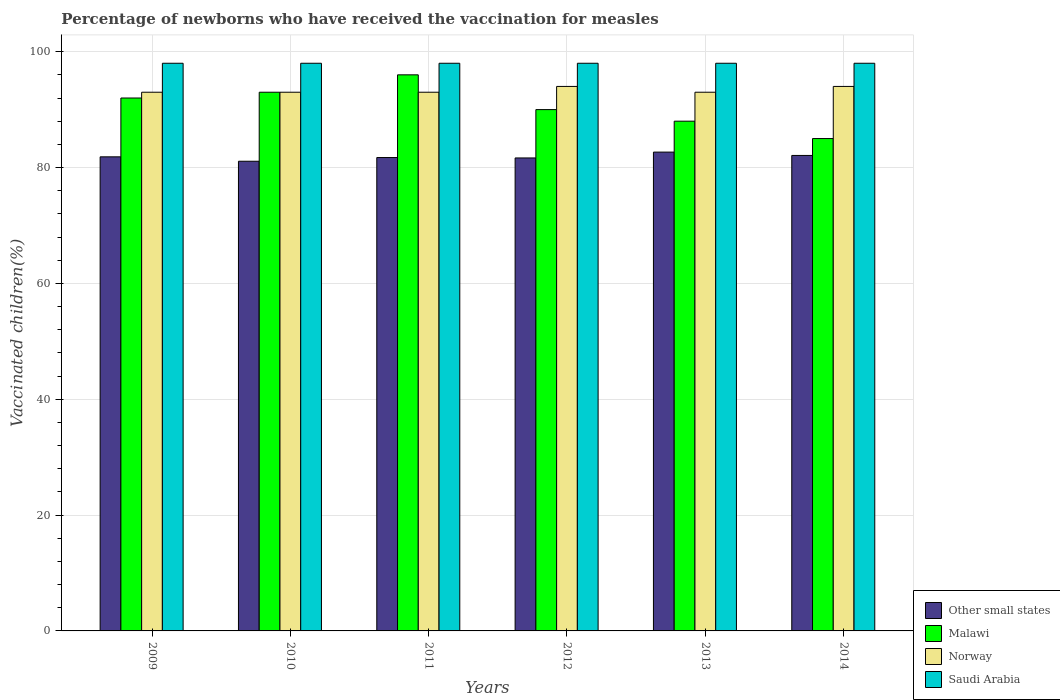What is the label of the 5th group of bars from the left?
Give a very brief answer. 2013. What is the percentage of vaccinated children in Other small states in 2012?
Provide a short and direct response. 81.65. Across all years, what is the maximum percentage of vaccinated children in Saudi Arabia?
Provide a short and direct response. 98. Across all years, what is the minimum percentage of vaccinated children in Other small states?
Make the answer very short. 81.08. In which year was the percentage of vaccinated children in Norway minimum?
Keep it short and to the point. 2009. What is the total percentage of vaccinated children in Norway in the graph?
Your response must be concise. 560. What is the difference between the percentage of vaccinated children in Norway in 2012 and that in 2013?
Your answer should be compact. 1. What is the difference between the percentage of vaccinated children in Malawi in 2011 and the percentage of vaccinated children in Other small states in 2010?
Provide a succinct answer. 14.92. What is the average percentage of vaccinated children in Norway per year?
Ensure brevity in your answer.  93.33. In the year 2011, what is the difference between the percentage of vaccinated children in Malawi and percentage of vaccinated children in Other small states?
Make the answer very short. 14.28. In how many years, is the percentage of vaccinated children in Malawi greater than 4 %?
Your response must be concise. 6. What is the ratio of the percentage of vaccinated children in Saudi Arabia in 2013 to that in 2014?
Your answer should be very brief. 1. Is the difference between the percentage of vaccinated children in Malawi in 2011 and 2014 greater than the difference between the percentage of vaccinated children in Other small states in 2011 and 2014?
Ensure brevity in your answer.  Yes. What is the difference between the highest and the second highest percentage of vaccinated children in Malawi?
Your response must be concise. 3. What is the difference between the highest and the lowest percentage of vaccinated children in Malawi?
Offer a terse response. 11. In how many years, is the percentage of vaccinated children in Norway greater than the average percentage of vaccinated children in Norway taken over all years?
Offer a terse response. 2. Is it the case that in every year, the sum of the percentage of vaccinated children in Other small states and percentage of vaccinated children in Norway is greater than the sum of percentage of vaccinated children in Saudi Arabia and percentage of vaccinated children in Malawi?
Keep it short and to the point. Yes. What does the 3rd bar from the left in 2013 represents?
Your answer should be compact. Norway. Is it the case that in every year, the sum of the percentage of vaccinated children in Norway and percentage of vaccinated children in Saudi Arabia is greater than the percentage of vaccinated children in Malawi?
Ensure brevity in your answer.  Yes. How many bars are there?
Your answer should be very brief. 24. How many years are there in the graph?
Provide a succinct answer. 6. What is the difference between two consecutive major ticks on the Y-axis?
Provide a short and direct response. 20. How are the legend labels stacked?
Ensure brevity in your answer.  Vertical. What is the title of the graph?
Your answer should be very brief. Percentage of newborns who have received the vaccination for measles. Does "Libya" appear as one of the legend labels in the graph?
Offer a terse response. No. What is the label or title of the X-axis?
Offer a terse response. Years. What is the label or title of the Y-axis?
Provide a succinct answer. Vaccinated children(%). What is the Vaccinated children(%) in Other small states in 2009?
Provide a succinct answer. 81.85. What is the Vaccinated children(%) of Malawi in 2009?
Give a very brief answer. 92. What is the Vaccinated children(%) in Norway in 2009?
Ensure brevity in your answer.  93. What is the Vaccinated children(%) in Saudi Arabia in 2009?
Your response must be concise. 98. What is the Vaccinated children(%) of Other small states in 2010?
Offer a very short reply. 81.08. What is the Vaccinated children(%) of Malawi in 2010?
Your response must be concise. 93. What is the Vaccinated children(%) in Norway in 2010?
Your response must be concise. 93. What is the Vaccinated children(%) of Saudi Arabia in 2010?
Keep it short and to the point. 98. What is the Vaccinated children(%) of Other small states in 2011?
Offer a very short reply. 81.72. What is the Vaccinated children(%) in Malawi in 2011?
Make the answer very short. 96. What is the Vaccinated children(%) in Norway in 2011?
Your answer should be very brief. 93. What is the Vaccinated children(%) in Other small states in 2012?
Provide a succinct answer. 81.65. What is the Vaccinated children(%) of Norway in 2012?
Your response must be concise. 94. What is the Vaccinated children(%) of Other small states in 2013?
Your answer should be compact. 82.66. What is the Vaccinated children(%) of Malawi in 2013?
Your answer should be compact. 88. What is the Vaccinated children(%) in Norway in 2013?
Ensure brevity in your answer.  93. What is the Vaccinated children(%) of Saudi Arabia in 2013?
Your answer should be very brief. 98. What is the Vaccinated children(%) in Other small states in 2014?
Your answer should be very brief. 82.09. What is the Vaccinated children(%) of Norway in 2014?
Your response must be concise. 94. Across all years, what is the maximum Vaccinated children(%) in Other small states?
Your answer should be very brief. 82.66. Across all years, what is the maximum Vaccinated children(%) in Malawi?
Provide a succinct answer. 96. Across all years, what is the maximum Vaccinated children(%) of Norway?
Provide a short and direct response. 94. Across all years, what is the maximum Vaccinated children(%) of Saudi Arabia?
Give a very brief answer. 98. Across all years, what is the minimum Vaccinated children(%) in Other small states?
Provide a succinct answer. 81.08. Across all years, what is the minimum Vaccinated children(%) in Norway?
Provide a short and direct response. 93. What is the total Vaccinated children(%) of Other small states in the graph?
Give a very brief answer. 491.05. What is the total Vaccinated children(%) of Malawi in the graph?
Your answer should be compact. 544. What is the total Vaccinated children(%) in Norway in the graph?
Keep it short and to the point. 560. What is the total Vaccinated children(%) in Saudi Arabia in the graph?
Your response must be concise. 588. What is the difference between the Vaccinated children(%) of Other small states in 2009 and that in 2010?
Offer a very short reply. 0.76. What is the difference between the Vaccinated children(%) in Malawi in 2009 and that in 2010?
Give a very brief answer. -1. What is the difference between the Vaccinated children(%) in Other small states in 2009 and that in 2011?
Give a very brief answer. 0.12. What is the difference between the Vaccinated children(%) in Norway in 2009 and that in 2011?
Give a very brief answer. 0. What is the difference between the Vaccinated children(%) of Saudi Arabia in 2009 and that in 2011?
Your response must be concise. 0. What is the difference between the Vaccinated children(%) of Other small states in 2009 and that in 2012?
Give a very brief answer. 0.19. What is the difference between the Vaccinated children(%) of Malawi in 2009 and that in 2012?
Provide a succinct answer. 2. What is the difference between the Vaccinated children(%) of Saudi Arabia in 2009 and that in 2012?
Make the answer very short. 0. What is the difference between the Vaccinated children(%) of Other small states in 2009 and that in 2013?
Give a very brief answer. -0.82. What is the difference between the Vaccinated children(%) in Malawi in 2009 and that in 2013?
Your response must be concise. 4. What is the difference between the Vaccinated children(%) in Norway in 2009 and that in 2013?
Ensure brevity in your answer.  0. What is the difference between the Vaccinated children(%) of Saudi Arabia in 2009 and that in 2013?
Ensure brevity in your answer.  0. What is the difference between the Vaccinated children(%) of Other small states in 2009 and that in 2014?
Ensure brevity in your answer.  -0.24. What is the difference between the Vaccinated children(%) of Malawi in 2009 and that in 2014?
Offer a very short reply. 7. What is the difference between the Vaccinated children(%) of Other small states in 2010 and that in 2011?
Offer a terse response. -0.64. What is the difference between the Vaccinated children(%) in Saudi Arabia in 2010 and that in 2011?
Provide a short and direct response. 0. What is the difference between the Vaccinated children(%) in Other small states in 2010 and that in 2012?
Your response must be concise. -0.57. What is the difference between the Vaccinated children(%) of Saudi Arabia in 2010 and that in 2012?
Offer a very short reply. 0. What is the difference between the Vaccinated children(%) in Other small states in 2010 and that in 2013?
Make the answer very short. -1.58. What is the difference between the Vaccinated children(%) of Malawi in 2010 and that in 2013?
Offer a terse response. 5. What is the difference between the Vaccinated children(%) in Norway in 2010 and that in 2013?
Ensure brevity in your answer.  0. What is the difference between the Vaccinated children(%) in Saudi Arabia in 2010 and that in 2013?
Your answer should be compact. 0. What is the difference between the Vaccinated children(%) of Other small states in 2010 and that in 2014?
Offer a very short reply. -1. What is the difference between the Vaccinated children(%) in Malawi in 2010 and that in 2014?
Your response must be concise. 8. What is the difference between the Vaccinated children(%) of Other small states in 2011 and that in 2012?
Your answer should be compact. 0.07. What is the difference between the Vaccinated children(%) in Norway in 2011 and that in 2012?
Give a very brief answer. -1. What is the difference between the Vaccinated children(%) in Other small states in 2011 and that in 2013?
Your response must be concise. -0.94. What is the difference between the Vaccinated children(%) of Norway in 2011 and that in 2013?
Your response must be concise. 0. What is the difference between the Vaccinated children(%) of Other small states in 2011 and that in 2014?
Make the answer very short. -0.36. What is the difference between the Vaccinated children(%) of Malawi in 2011 and that in 2014?
Provide a succinct answer. 11. What is the difference between the Vaccinated children(%) in Saudi Arabia in 2011 and that in 2014?
Your answer should be compact. 0. What is the difference between the Vaccinated children(%) in Other small states in 2012 and that in 2013?
Provide a short and direct response. -1.01. What is the difference between the Vaccinated children(%) in Malawi in 2012 and that in 2013?
Your answer should be very brief. 2. What is the difference between the Vaccinated children(%) in Saudi Arabia in 2012 and that in 2013?
Keep it short and to the point. 0. What is the difference between the Vaccinated children(%) in Other small states in 2012 and that in 2014?
Your response must be concise. -0.43. What is the difference between the Vaccinated children(%) in Other small states in 2013 and that in 2014?
Offer a very short reply. 0.58. What is the difference between the Vaccinated children(%) of Other small states in 2009 and the Vaccinated children(%) of Malawi in 2010?
Keep it short and to the point. -11.15. What is the difference between the Vaccinated children(%) of Other small states in 2009 and the Vaccinated children(%) of Norway in 2010?
Offer a very short reply. -11.15. What is the difference between the Vaccinated children(%) in Other small states in 2009 and the Vaccinated children(%) in Saudi Arabia in 2010?
Your answer should be very brief. -16.15. What is the difference between the Vaccinated children(%) of Malawi in 2009 and the Vaccinated children(%) of Norway in 2010?
Your response must be concise. -1. What is the difference between the Vaccinated children(%) of Malawi in 2009 and the Vaccinated children(%) of Saudi Arabia in 2010?
Provide a succinct answer. -6. What is the difference between the Vaccinated children(%) in Other small states in 2009 and the Vaccinated children(%) in Malawi in 2011?
Your response must be concise. -14.15. What is the difference between the Vaccinated children(%) of Other small states in 2009 and the Vaccinated children(%) of Norway in 2011?
Keep it short and to the point. -11.15. What is the difference between the Vaccinated children(%) in Other small states in 2009 and the Vaccinated children(%) in Saudi Arabia in 2011?
Your response must be concise. -16.15. What is the difference between the Vaccinated children(%) in Norway in 2009 and the Vaccinated children(%) in Saudi Arabia in 2011?
Offer a terse response. -5. What is the difference between the Vaccinated children(%) of Other small states in 2009 and the Vaccinated children(%) of Malawi in 2012?
Make the answer very short. -8.15. What is the difference between the Vaccinated children(%) in Other small states in 2009 and the Vaccinated children(%) in Norway in 2012?
Your response must be concise. -12.15. What is the difference between the Vaccinated children(%) in Other small states in 2009 and the Vaccinated children(%) in Saudi Arabia in 2012?
Offer a very short reply. -16.15. What is the difference between the Vaccinated children(%) in Norway in 2009 and the Vaccinated children(%) in Saudi Arabia in 2012?
Offer a terse response. -5. What is the difference between the Vaccinated children(%) in Other small states in 2009 and the Vaccinated children(%) in Malawi in 2013?
Offer a terse response. -6.15. What is the difference between the Vaccinated children(%) of Other small states in 2009 and the Vaccinated children(%) of Norway in 2013?
Your answer should be very brief. -11.15. What is the difference between the Vaccinated children(%) in Other small states in 2009 and the Vaccinated children(%) in Saudi Arabia in 2013?
Your response must be concise. -16.15. What is the difference between the Vaccinated children(%) of Malawi in 2009 and the Vaccinated children(%) of Norway in 2013?
Provide a succinct answer. -1. What is the difference between the Vaccinated children(%) in Norway in 2009 and the Vaccinated children(%) in Saudi Arabia in 2013?
Your answer should be very brief. -5. What is the difference between the Vaccinated children(%) in Other small states in 2009 and the Vaccinated children(%) in Malawi in 2014?
Make the answer very short. -3.15. What is the difference between the Vaccinated children(%) in Other small states in 2009 and the Vaccinated children(%) in Norway in 2014?
Provide a short and direct response. -12.15. What is the difference between the Vaccinated children(%) in Other small states in 2009 and the Vaccinated children(%) in Saudi Arabia in 2014?
Your answer should be compact. -16.15. What is the difference between the Vaccinated children(%) in Malawi in 2009 and the Vaccinated children(%) in Saudi Arabia in 2014?
Offer a terse response. -6. What is the difference between the Vaccinated children(%) of Norway in 2009 and the Vaccinated children(%) of Saudi Arabia in 2014?
Keep it short and to the point. -5. What is the difference between the Vaccinated children(%) in Other small states in 2010 and the Vaccinated children(%) in Malawi in 2011?
Make the answer very short. -14.92. What is the difference between the Vaccinated children(%) of Other small states in 2010 and the Vaccinated children(%) of Norway in 2011?
Offer a very short reply. -11.92. What is the difference between the Vaccinated children(%) of Other small states in 2010 and the Vaccinated children(%) of Saudi Arabia in 2011?
Your answer should be very brief. -16.92. What is the difference between the Vaccinated children(%) in Malawi in 2010 and the Vaccinated children(%) in Norway in 2011?
Your answer should be compact. 0. What is the difference between the Vaccinated children(%) of Other small states in 2010 and the Vaccinated children(%) of Malawi in 2012?
Give a very brief answer. -8.92. What is the difference between the Vaccinated children(%) of Other small states in 2010 and the Vaccinated children(%) of Norway in 2012?
Make the answer very short. -12.92. What is the difference between the Vaccinated children(%) in Other small states in 2010 and the Vaccinated children(%) in Saudi Arabia in 2012?
Ensure brevity in your answer.  -16.92. What is the difference between the Vaccinated children(%) of Other small states in 2010 and the Vaccinated children(%) of Malawi in 2013?
Your answer should be very brief. -6.92. What is the difference between the Vaccinated children(%) of Other small states in 2010 and the Vaccinated children(%) of Norway in 2013?
Ensure brevity in your answer.  -11.92. What is the difference between the Vaccinated children(%) of Other small states in 2010 and the Vaccinated children(%) of Saudi Arabia in 2013?
Offer a very short reply. -16.92. What is the difference between the Vaccinated children(%) in Malawi in 2010 and the Vaccinated children(%) in Saudi Arabia in 2013?
Offer a very short reply. -5. What is the difference between the Vaccinated children(%) of Norway in 2010 and the Vaccinated children(%) of Saudi Arabia in 2013?
Your answer should be very brief. -5. What is the difference between the Vaccinated children(%) of Other small states in 2010 and the Vaccinated children(%) of Malawi in 2014?
Keep it short and to the point. -3.92. What is the difference between the Vaccinated children(%) of Other small states in 2010 and the Vaccinated children(%) of Norway in 2014?
Offer a very short reply. -12.92. What is the difference between the Vaccinated children(%) of Other small states in 2010 and the Vaccinated children(%) of Saudi Arabia in 2014?
Make the answer very short. -16.92. What is the difference between the Vaccinated children(%) in Malawi in 2010 and the Vaccinated children(%) in Norway in 2014?
Your answer should be compact. -1. What is the difference between the Vaccinated children(%) in Malawi in 2010 and the Vaccinated children(%) in Saudi Arabia in 2014?
Your response must be concise. -5. What is the difference between the Vaccinated children(%) of Norway in 2010 and the Vaccinated children(%) of Saudi Arabia in 2014?
Make the answer very short. -5. What is the difference between the Vaccinated children(%) of Other small states in 2011 and the Vaccinated children(%) of Malawi in 2012?
Provide a short and direct response. -8.28. What is the difference between the Vaccinated children(%) in Other small states in 2011 and the Vaccinated children(%) in Norway in 2012?
Offer a very short reply. -12.28. What is the difference between the Vaccinated children(%) in Other small states in 2011 and the Vaccinated children(%) in Saudi Arabia in 2012?
Offer a terse response. -16.28. What is the difference between the Vaccinated children(%) of Malawi in 2011 and the Vaccinated children(%) of Saudi Arabia in 2012?
Make the answer very short. -2. What is the difference between the Vaccinated children(%) of Other small states in 2011 and the Vaccinated children(%) of Malawi in 2013?
Offer a terse response. -6.28. What is the difference between the Vaccinated children(%) in Other small states in 2011 and the Vaccinated children(%) in Norway in 2013?
Provide a short and direct response. -11.28. What is the difference between the Vaccinated children(%) of Other small states in 2011 and the Vaccinated children(%) of Saudi Arabia in 2013?
Your answer should be very brief. -16.28. What is the difference between the Vaccinated children(%) in Other small states in 2011 and the Vaccinated children(%) in Malawi in 2014?
Give a very brief answer. -3.28. What is the difference between the Vaccinated children(%) of Other small states in 2011 and the Vaccinated children(%) of Norway in 2014?
Offer a terse response. -12.28. What is the difference between the Vaccinated children(%) in Other small states in 2011 and the Vaccinated children(%) in Saudi Arabia in 2014?
Your answer should be compact. -16.28. What is the difference between the Vaccinated children(%) of Malawi in 2011 and the Vaccinated children(%) of Norway in 2014?
Give a very brief answer. 2. What is the difference between the Vaccinated children(%) of Malawi in 2011 and the Vaccinated children(%) of Saudi Arabia in 2014?
Make the answer very short. -2. What is the difference between the Vaccinated children(%) of Norway in 2011 and the Vaccinated children(%) of Saudi Arabia in 2014?
Provide a succinct answer. -5. What is the difference between the Vaccinated children(%) of Other small states in 2012 and the Vaccinated children(%) of Malawi in 2013?
Ensure brevity in your answer.  -6.35. What is the difference between the Vaccinated children(%) in Other small states in 2012 and the Vaccinated children(%) in Norway in 2013?
Provide a succinct answer. -11.35. What is the difference between the Vaccinated children(%) of Other small states in 2012 and the Vaccinated children(%) of Saudi Arabia in 2013?
Make the answer very short. -16.35. What is the difference between the Vaccinated children(%) of Malawi in 2012 and the Vaccinated children(%) of Norway in 2013?
Your answer should be very brief. -3. What is the difference between the Vaccinated children(%) of Other small states in 2012 and the Vaccinated children(%) of Malawi in 2014?
Ensure brevity in your answer.  -3.35. What is the difference between the Vaccinated children(%) in Other small states in 2012 and the Vaccinated children(%) in Norway in 2014?
Offer a terse response. -12.35. What is the difference between the Vaccinated children(%) in Other small states in 2012 and the Vaccinated children(%) in Saudi Arabia in 2014?
Your answer should be very brief. -16.35. What is the difference between the Vaccinated children(%) of Malawi in 2012 and the Vaccinated children(%) of Norway in 2014?
Give a very brief answer. -4. What is the difference between the Vaccinated children(%) of Norway in 2012 and the Vaccinated children(%) of Saudi Arabia in 2014?
Your answer should be very brief. -4. What is the difference between the Vaccinated children(%) of Other small states in 2013 and the Vaccinated children(%) of Malawi in 2014?
Make the answer very short. -2.34. What is the difference between the Vaccinated children(%) in Other small states in 2013 and the Vaccinated children(%) in Norway in 2014?
Provide a short and direct response. -11.34. What is the difference between the Vaccinated children(%) of Other small states in 2013 and the Vaccinated children(%) of Saudi Arabia in 2014?
Provide a short and direct response. -15.34. What is the difference between the Vaccinated children(%) of Malawi in 2013 and the Vaccinated children(%) of Norway in 2014?
Provide a short and direct response. -6. What is the difference between the Vaccinated children(%) in Malawi in 2013 and the Vaccinated children(%) in Saudi Arabia in 2014?
Provide a short and direct response. -10. What is the average Vaccinated children(%) in Other small states per year?
Provide a succinct answer. 81.84. What is the average Vaccinated children(%) of Malawi per year?
Keep it short and to the point. 90.67. What is the average Vaccinated children(%) of Norway per year?
Ensure brevity in your answer.  93.33. What is the average Vaccinated children(%) in Saudi Arabia per year?
Provide a succinct answer. 98. In the year 2009, what is the difference between the Vaccinated children(%) of Other small states and Vaccinated children(%) of Malawi?
Provide a short and direct response. -10.15. In the year 2009, what is the difference between the Vaccinated children(%) of Other small states and Vaccinated children(%) of Norway?
Your response must be concise. -11.15. In the year 2009, what is the difference between the Vaccinated children(%) in Other small states and Vaccinated children(%) in Saudi Arabia?
Offer a terse response. -16.15. In the year 2009, what is the difference between the Vaccinated children(%) in Malawi and Vaccinated children(%) in Saudi Arabia?
Keep it short and to the point. -6. In the year 2010, what is the difference between the Vaccinated children(%) in Other small states and Vaccinated children(%) in Malawi?
Keep it short and to the point. -11.92. In the year 2010, what is the difference between the Vaccinated children(%) of Other small states and Vaccinated children(%) of Norway?
Provide a succinct answer. -11.92. In the year 2010, what is the difference between the Vaccinated children(%) of Other small states and Vaccinated children(%) of Saudi Arabia?
Offer a terse response. -16.92. In the year 2011, what is the difference between the Vaccinated children(%) of Other small states and Vaccinated children(%) of Malawi?
Keep it short and to the point. -14.28. In the year 2011, what is the difference between the Vaccinated children(%) in Other small states and Vaccinated children(%) in Norway?
Offer a very short reply. -11.28. In the year 2011, what is the difference between the Vaccinated children(%) of Other small states and Vaccinated children(%) of Saudi Arabia?
Your response must be concise. -16.28. In the year 2011, what is the difference between the Vaccinated children(%) in Malawi and Vaccinated children(%) in Norway?
Give a very brief answer. 3. In the year 2012, what is the difference between the Vaccinated children(%) in Other small states and Vaccinated children(%) in Malawi?
Provide a short and direct response. -8.35. In the year 2012, what is the difference between the Vaccinated children(%) in Other small states and Vaccinated children(%) in Norway?
Offer a very short reply. -12.35. In the year 2012, what is the difference between the Vaccinated children(%) of Other small states and Vaccinated children(%) of Saudi Arabia?
Offer a terse response. -16.35. In the year 2012, what is the difference between the Vaccinated children(%) in Malawi and Vaccinated children(%) in Saudi Arabia?
Make the answer very short. -8. In the year 2013, what is the difference between the Vaccinated children(%) in Other small states and Vaccinated children(%) in Malawi?
Provide a short and direct response. -5.34. In the year 2013, what is the difference between the Vaccinated children(%) of Other small states and Vaccinated children(%) of Norway?
Give a very brief answer. -10.34. In the year 2013, what is the difference between the Vaccinated children(%) in Other small states and Vaccinated children(%) in Saudi Arabia?
Give a very brief answer. -15.34. In the year 2014, what is the difference between the Vaccinated children(%) in Other small states and Vaccinated children(%) in Malawi?
Keep it short and to the point. -2.91. In the year 2014, what is the difference between the Vaccinated children(%) in Other small states and Vaccinated children(%) in Norway?
Make the answer very short. -11.91. In the year 2014, what is the difference between the Vaccinated children(%) in Other small states and Vaccinated children(%) in Saudi Arabia?
Make the answer very short. -15.91. In the year 2014, what is the difference between the Vaccinated children(%) in Malawi and Vaccinated children(%) in Norway?
Make the answer very short. -9. What is the ratio of the Vaccinated children(%) of Other small states in 2009 to that in 2010?
Give a very brief answer. 1.01. What is the ratio of the Vaccinated children(%) of Malawi in 2009 to that in 2011?
Your answer should be compact. 0.96. What is the ratio of the Vaccinated children(%) of Norway in 2009 to that in 2011?
Your answer should be compact. 1. What is the ratio of the Vaccinated children(%) of Saudi Arabia in 2009 to that in 2011?
Provide a short and direct response. 1. What is the ratio of the Vaccinated children(%) of Other small states in 2009 to that in 2012?
Your answer should be compact. 1. What is the ratio of the Vaccinated children(%) of Malawi in 2009 to that in 2012?
Give a very brief answer. 1.02. What is the ratio of the Vaccinated children(%) of Norway in 2009 to that in 2012?
Provide a succinct answer. 0.99. What is the ratio of the Vaccinated children(%) in Other small states in 2009 to that in 2013?
Provide a short and direct response. 0.99. What is the ratio of the Vaccinated children(%) of Malawi in 2009 to that in 2013?
Give a very brief answer. 1.05. What is the ratio of the Vaccinated children(%) in Malawi in 2009 to that in 2014?
Ensure brevity in your answer.  1.08. What is the ratio of the Vaccinated children(%) in Malawi in 2010 to that in 2011?
Keep it short and to the point. 0.97. What is the ratio of the Vaccinated children(%) in Other small states in 2010 to that in 2012?
Make the answer very short. 0.99. What is the ratio of the Vaccinated children(%) in Malawi in 2010 to that in 2012?
Your answer should be compact. 1.03. What is the ratio of the Vaccinated children(%) in Saudi Arabia in 2010 to that in 2012?
Offer a terse response. 1. What is the ratio of the Vaccinated children(%) of Other small states in 2010 to that in 2013?
Your response must be concise. 0.98. What is the ratio of the Vaccinated children(%) of Malawi in 2010 to that in 2013?
Keep it short and to the point. 1.06. What is the ratio of the Vaccinated children(%) in Norway in 2010 to that in 2013?
Offer a very short reply. 1. What is the ratio of the Vaccinated children(%) of Malawi in 2010 to that in 2014?
Offer a terse response. 1.09. What is the ratio of the Vaccinated children(%) in Malawi in 2011 to that in 2012?
Offer a very short reply. 1.07. What is the ratio of the Vaccinated children(%) in Other small states in 2011 to that in 2013?
Your answer should be very brief. 0.99. What is the ratio of the Vaccinated children(%) in Malawi in 2011 to that in 2013?
Your answer should be compact. 1.09. What is the ratio of the Vaccinated children(%) of Norway in 2011 to that in 2013?
Your response must be concise. 1. What is the ratio of the Vaccinated children(%) in Other small states in 2011 to that in 2014?
Your answer should be compact. 1. What is the ratio of the Vaccinated children(%) of Malawi in 2011 to that in 2014?
Keep it short and to the point. 1.13. What is the ratio of the Vaccinated children(%) of Other small states in 2012 to that in 2013?
Offer a very short reply. 0.99. What is the ratio of the Vaccinated children(%) in Malawi in 2012 to that in 2013?
Keep it short and to the point. 1.02. What is the ratio of the Vaccinated children(%) in Norway in 2012 to that in 2013?
Make the answer very short. 1.01. What is the ratio of the Vaccinated children(%) of Saudi Arabia in 2012 to that in 2013?
Your response must be concise. 1. What is the ratio of the Vaccinated children(%) in Other small states in 2012 to that in 2014?
Ensure brevity in your answer.  0.99. What is the ratio of the Vaccinated children(%) in Malawi in 2012 to that in 2014?
Give a very brief answer. 1.06. What is the ratio of the Vaccinated children(%) of Norway in 2012 to that in 2014?
Your answer should be very brief. 1. What is the ratio of the Vaccinated children(%) of Saudi Arabia in 2012 to that in 2014?
Offer a terse response. 1. What is the ratio of the Vaccinated children(%) in Malawi in 2013 to that in 2014?
Provide a succinct answer. 1.04. What is the difference between the highest and the second highest Vaccinated children(%) of Other small states?
Your response must be concise. 0.58. What is the difference between the highest and the second highest Vaccinated children(%) of Saudi Arabia?
Make the answer very short. 0. What is the difference between the highest and the lowest Vaccinated children(%) of Other small states?
Make the answer very short. 1.58. What is the difference between the highest and the lowest Vaccinated children(%) of Malawi?
Provide a succinct answer. 11. 